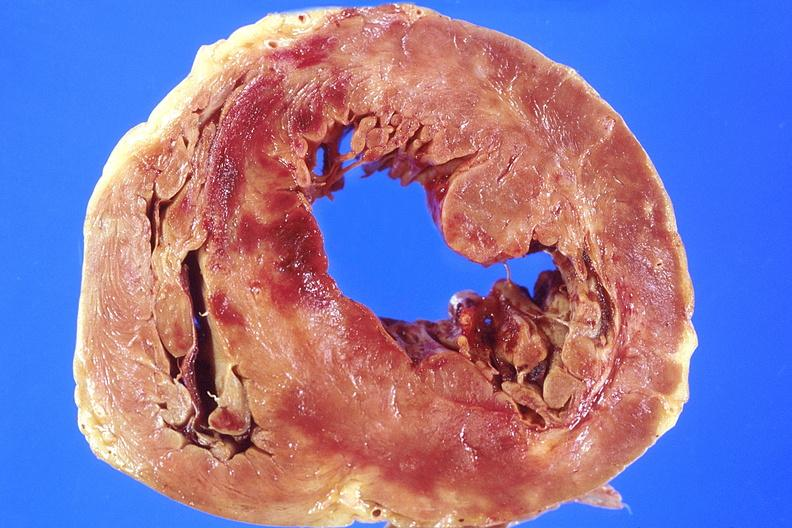does this image show heart, acute myocardial infarction, anterior wall?
Answer the question using a single word or phrase. Yes 